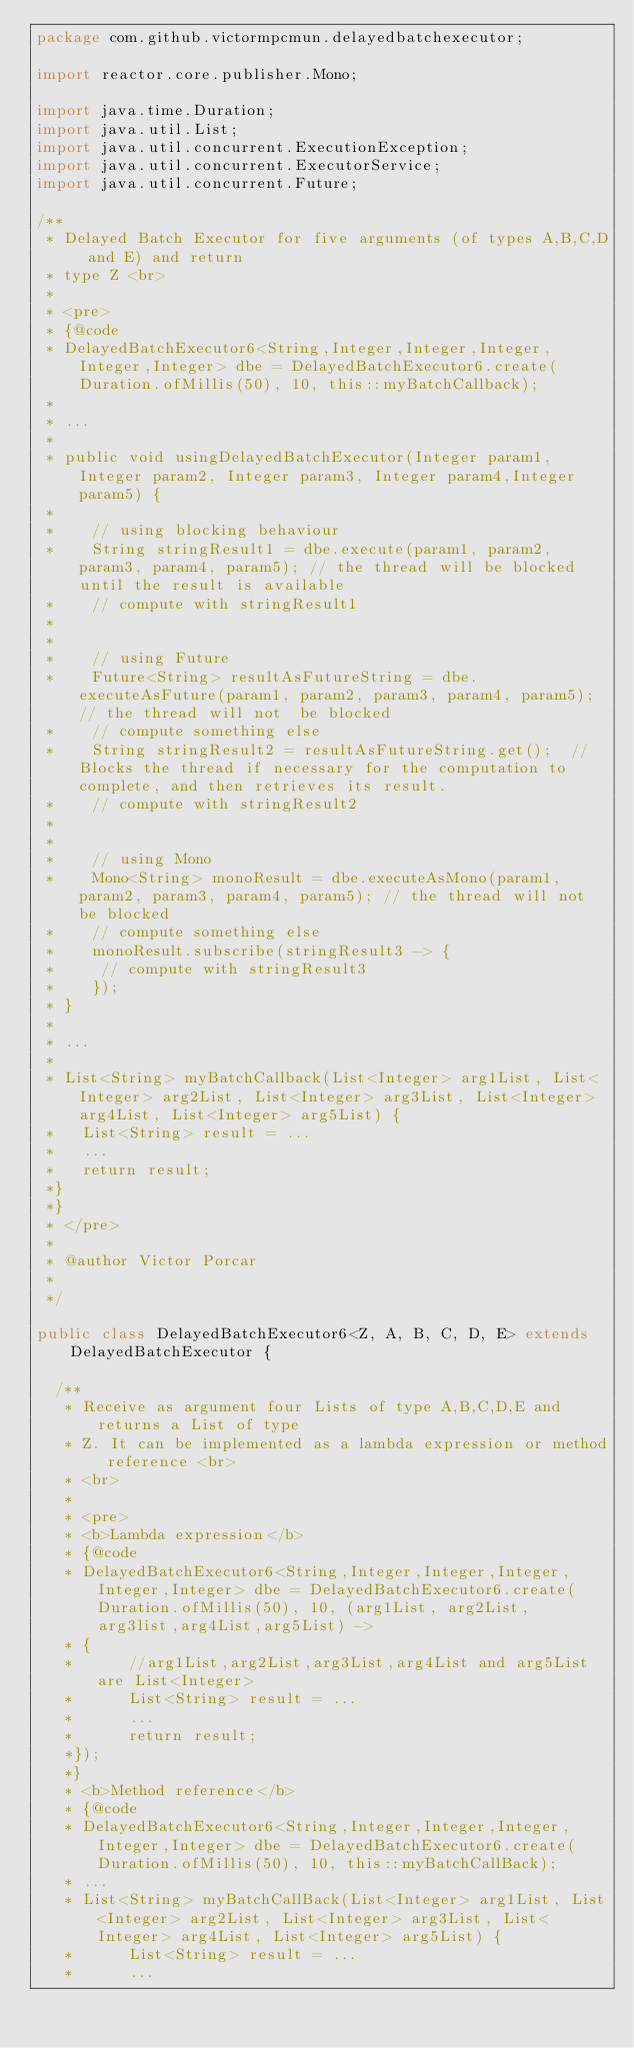Convert code to text. <code><loc_0><loc_0><loc_500><loc_500><_Java_>package com.github.victormpcmun.delayedbatchexecutor;

import reactor.core.publisher.Mono;

import java.time.Duration;
import java.util.List;
import java.util.concurrent.ExecutionException;
import java.util.concurrent.ExecutorService;
import java.util.concurrent.Future;

/**
 * Delayed Batch Executor for five arguments (of types A,B,C,D and E) and return
 * type Z <br>
 * 
 * <pre>
 * {@code
 * DelayedBatchExecutor6<String,Integer,Integer,Integer,Integer,Integer> dbe = DelayedBatchExecutor6.create(Duration.ofMillis(50), 10, this::myBatchCallback);
 *
 * ...
 *
 * public void usingDelayedBatchExecutor(Integer param1, Integer param2, Integer param3, Integer param4,Integer param5) {
 *
 *    // using blocking behaviour
 *    String stringResult1 = dbe.execute(param1, param2, param3, param4, param5); // the thread will be blocked until the result is available
 *    // compute with stringResult1
 *
 *
 *    // using Future
 *    Future<String> resultAsFutureString = dbe.executeAsFuture(param1, param2, param3, param4, param5); // the thread will not  be blocked
 *    // compute something else
 *    String stringResult2 = resultAsFutureString.get();  // Blocks the thread if necessary for the computation to complete, and then retrieves its result.
 *    // compute with stringResult2
 *
 *
 *    // using Mono
 *    Mono<String> monoResult = dbe.executeAsMono(param1, param2, param3, param4, param5); // the thread will not  be blocked
 *    // compute something else
 *    monoResult.subscribe(stringResult3 -> {
 *     // compute with stringResult3
 *    });
 * }
 *
 * ...
 *
 * List<String> myBatchCallback(List<Integer> arg1List, List<Integer> arg2List, List<Integer> arg3List, List<Integer> arg4List, List<Integer> arg5List) {
 *   List<String> result = ...
 *   ...
 *   return result;
 *}
 *}
 * </pre>
 * 
 * @author Victor Porcar
 *
 */

public class DelayedBatchExecutor6<Z, A, B, C, D, E> extends DelayedBatchExecutor {

	/**
	 * Receive as argument four Lists of type A,B,C,D,E and returns a List of type
	 * Z. It can be implemented as a lambda expression or method reference <br>
	 * <br>
	 * 
	 * <pre>
	 * <b>Lambda expression</b>
	 * {@code
	 * DelayedBatchExecutor6<String,Integer,Integer,Integer,Integer,Integer> dbe = DelayedBatchExecutor6.create(Duration.ofMillis(50), 10, (arg1List, arg2List, arg3list,arg4List,arg5List) ->
	 * {
	 *      //arg1List,arg2List,arg3List,arg4List and arg5List are List<Integer>
	 *      List<String> result = ...
	 *	    ...
	 *      return result;
	 *});
	 *}
	 * <b>Method reference</b>
	 * {@code
	 * DelayedBatchExecutor6<String,Integer,Integer,Integer,Integer,Integer> dbe = DelayedBatchExecutor6.create(Duration.ofMillis(50), 10, this::myBatchCallBack);
	 * ...
	 * List<String> myBatchCallBack(List<Integer> arg1List, List<Integer> arg2List, List<Integer> arg3List, List<Integer> arg4List, List<Integer> arg5List) {
	 *      List<String> result = ...
	 *	    ...</code> 